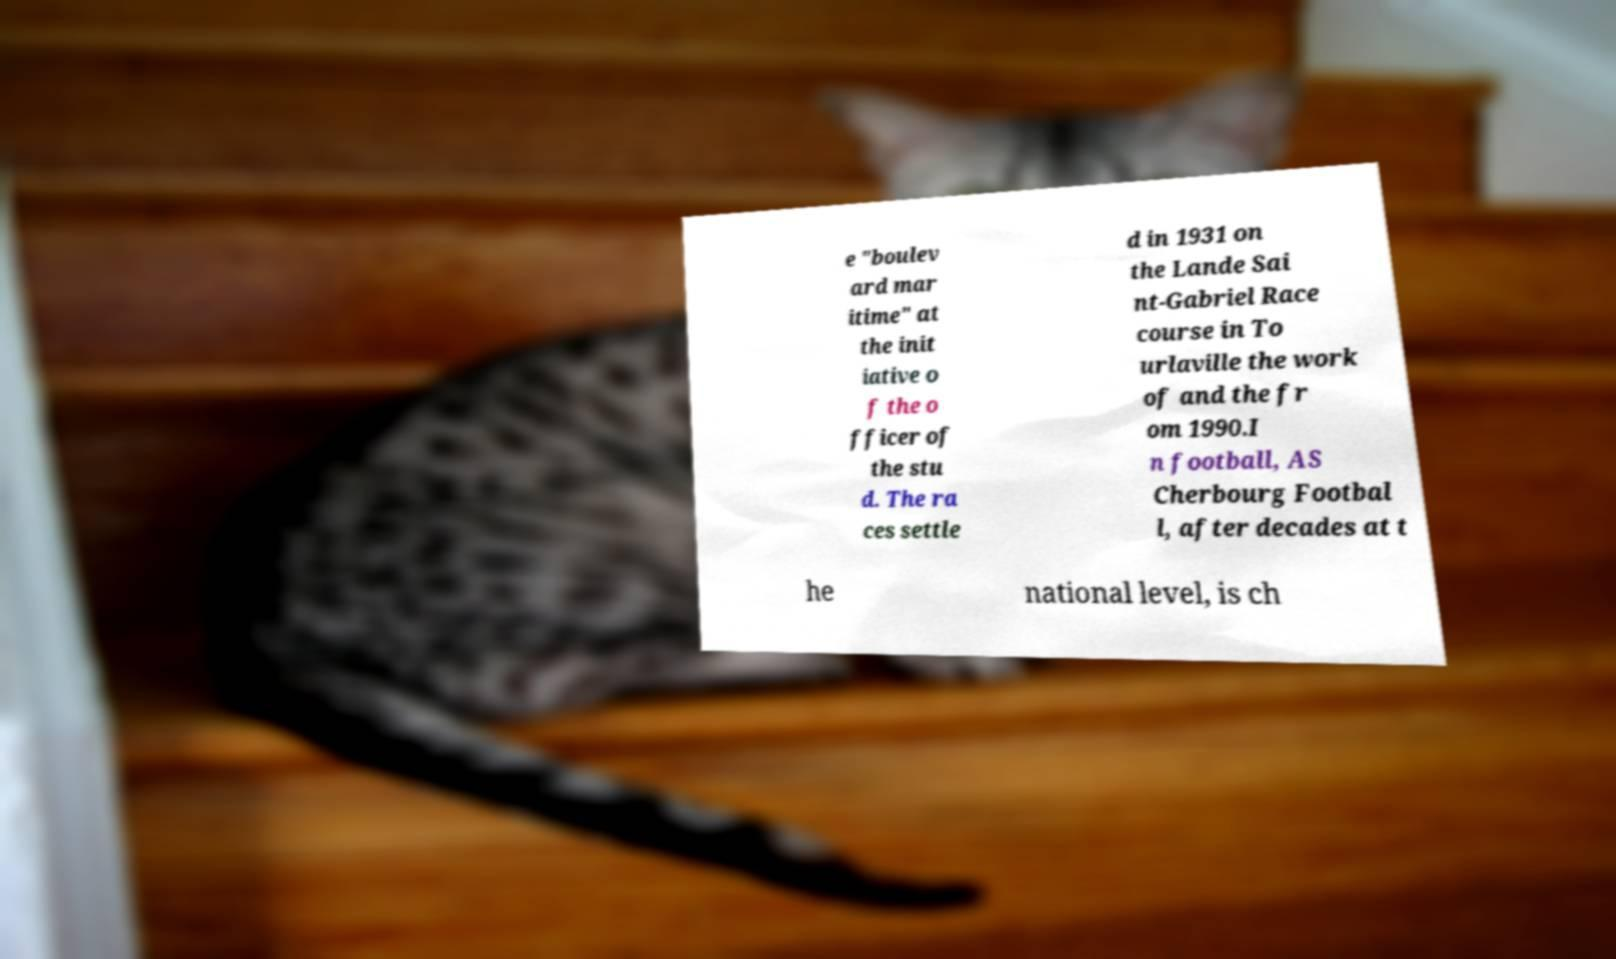There's text embedded in this image that I need extracted. Can you transcribe it verbatim? e "boulev ard mar itime" at the init iative o f the o fficer of the stu d. The ra ces settle d in 1931 on the Lande Sai nt-Gabriel Race course in To urlaville the work of and the fr om 1990.I n football, AS Cherbourg Footbal l, after decades at t he national level, is ch 